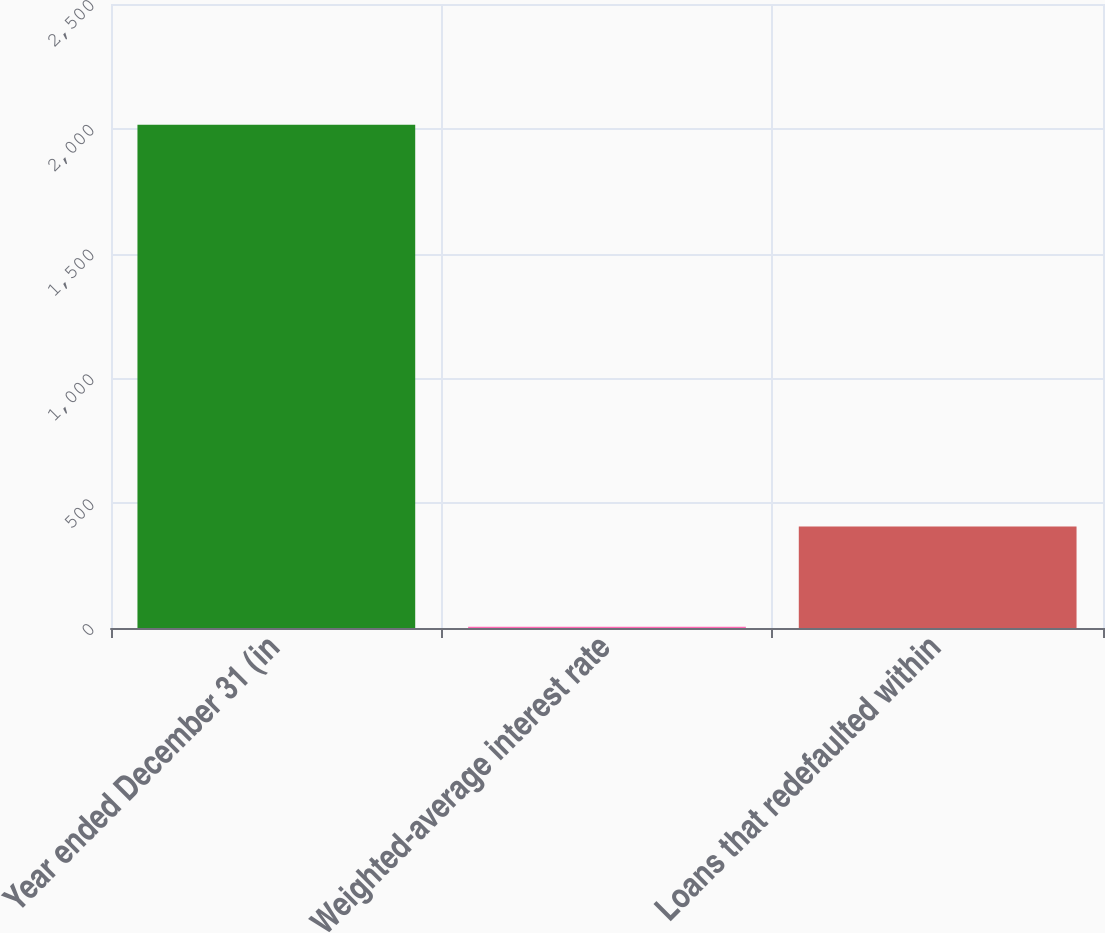Convert chart. <chart><loc_0><loc_0><loc_500><loc_500><bar_chart><fcel>Year ended December 31 (in<fcel>Weighted-average interest rate<fcel>Loans that redefaulted within<nl><fcel>2016<fcel>4.76<fcel>407<nl></chart> 